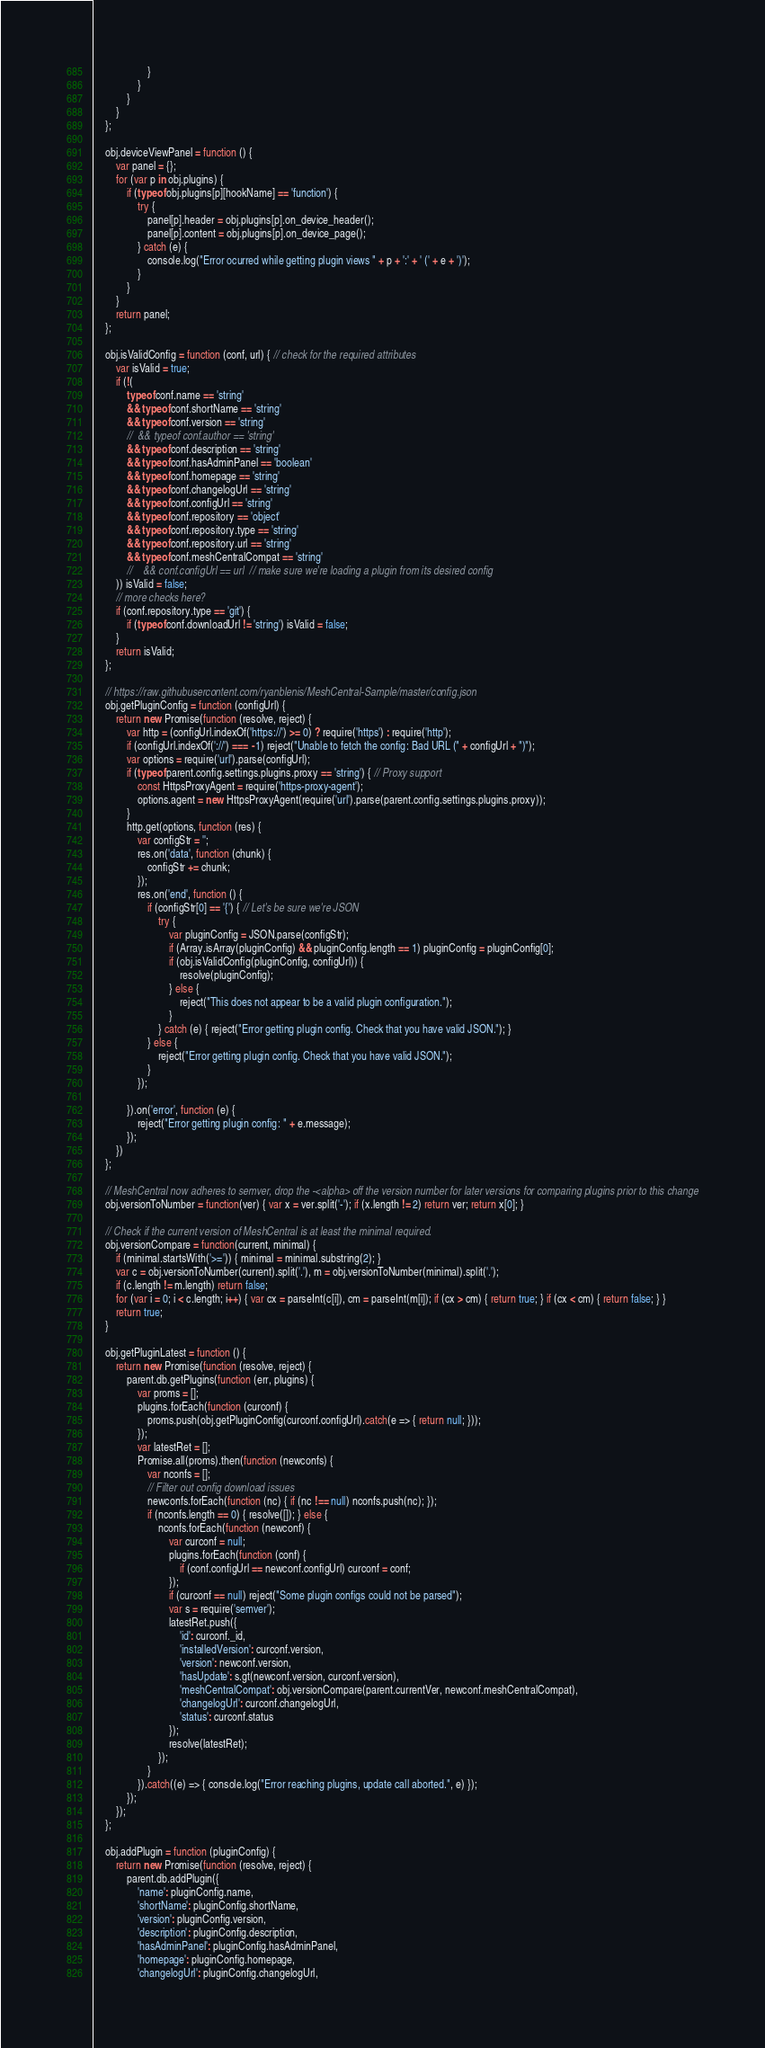<code> <loc_0><loc_0><loc_500><loc_500><_JavaScript_>                    }
                }
            }
        }
    };

    obj.deviceViewPanel = function () {
        var panel = {};
        for (var p in obj.plugins) {
            if (typeof obj.plugins[p][hookName] == 'function') {
                try {
                    panel[p].header = obj.plugins[p].on_device_header();
                    panel[p].content = obj.plugins[p].on_device_page();
                } catch (e) {
                    console.log("Error ocurred while getting plugin views " + p + ':' + ' (' + e + ')');
                }
            }
        }
        return panel;
    };

    obj.isValidConfig = function (conf, url) { // check for the required attributes
        var isValid = true;
        if (!(
            typeof conf.name == 'string'
            && typeof conf.shortName == 'string'
            && typeof conf.version == 'string'
            //  && typeof conf.author == 'string'
            && typeof conf.description == 'string'
            && typeof conf.hasAdminPanel == 'boolean'
            && typeof conf.homepage == 'string'
            && typeof conf.changelogUrl == 'string'
            && typeof conf.configUrl == 'string'
            && typeof conf.repository == 'object'
            && typeof conf.repository.type == 'string'
            && typeof conf.repository.url == 'string'
            && typeof conf.meshCentralCompat == 'string'
            //    && conf.configUrl == url  // make sure we're loading a plugin from its desired config
        )) isValid = false;
        // more checks here?
        if (conf.repository.type == 'git') {
            if (typeof conf.downloadUrl != 'string') isValid = false;
        }
        return isValid;
    };

    // https://raw.githubusercontent.com/ryanblenis/MeshCentral-Sample/master/config.json
    obj.getPluginConfig = function (configUrl) {
        return new Promise(function (resolve, reject) {
            var http = (configUrl.indexOf('https://') >= 0) ? require('https') : require('http');
            if (configUrl.indexOf('://') === -1) reject("Unable to fetch the config: Bad URL (" + configUrl + ")");
            var options = require('url').parse(configUrl);
            if (typeof parent.config.settings.plugins.proxy == 'string') { // Proxy support
                const HttpsProxyAgent = require('https-proxy-agent');
                options.agent = new HttpsProxyAgent(require('url').parse(parent.config.settings.plugins.proxy));
            }
            http.get(options, function (res) {
                var configStr = '';
                res.on('data', function (chunk) {
                    configStr += chunk;
                });
                res.on('end', function () {
                    if (configStr[0] == '{') { // Let's be sure we're JSON
                        try {
                            var pluginConfig = JSON.parse(configStr);
                            if (Array.isArray(pluginConfig) && pluginConfig.length == 1) pluginConfig = pluginConfig[0];
                            if (obj.isValidConfig(pluginConfig, configUrl)) {
                                resolve(pluginConfig);
                            } else {
                                reject("This does not appear to be a valid plugin configuration.");
                            }
                        } catch (e) { reject("Error getting plugin config. Check that you have valid JSON."); }
                    } else {
                        reject("Error getting plugin config. Check that you have valid JSON.");
                    }
                });

            }).on('error', function (e) {
                reject("Error getting plugin config: " + e.message);
            });
        })
    };

    // MeshCentral now adheres to semver, drop the -<alpha> off the version number for later versions for comparing plugins prior to this change
    obj.versionToNumber = function(ver) { var x = ver.split('-'); if (x.length != 2) return ver; return x[0]; }

    // Check if the current version of MeshCentral is at least the minimal required.
    obj.versionCompare = function(current, minimal) {
        if (minimal.startsWith('>=')) { minimal = minimal.substring(2); }
        var c = obj.versionToNumber(current).split('.'), m = obj.versionToNumber(minimal).split('.');
        if (c.length != m.length) return false;
        for (var i = 0; i < c.length; i++) { var cx = parseInt(c[i]), cm = parseInt(m[i]); if (cx > cm) { return true; } if (cx < cm) { return false; } }
        return true;
    }

    obj.getPluginLatest = function () {
        return new Promise(function (resolve, reject) {
            parent.db.getPlugins(function (err, plugins) {
                var proms = [];
                plugins.forEach(function (curconf) {
                    proms.push(obj.getPluginConfig(curconf.configUrl).catch(e => { return null; }));
                });
                var latestRet = [];
                Promise.all(proms).then(function (newconfs) {
                    var nconfs = [];
                    // Filter out config download issues
                    newconfs.forEach(function (nc) { if (nc !== null) nconfs.push(nc); });
                    if (nconfs.length == 0) { resolve([]); } else {
                        nconfs.forEach(function (newconf) {
                            var curconf = null;
                            plugins.forEach(function (conf) {
                                if (conf.configUrl == newconf.configUrl) curconf = conf;
                            });
                            if (curconf == null) reject("Some plugin configs could not be parsed");
                            var s = require('semver');
                            latestRet.push({
                                'id': curconf._id,
                                'installedVersion': curconf.version,
                                'version': newconf.version,
                                'hasUpdate': s.gt(newconf.version, curconf.version),
                                'meshCentralCompat': obj.versionCompare(parent.currentVer, newconf.meshCentralCompat),
                                'changelogUrl': curconf.changelogUrl,
                                'status': curconf.status
                            });
                            resolve(latestRet);
                        });
                    }
                }).catch((e) => { console.log("Error reaching plugins, update call aborted.", e) });
            });
        });
    };

    obj.addPlugin = function (pluginConfig) {
        return new Promise(function (resolve, reject) {
            parent.db.addPlugin({
                'name': pluginConfig.name,
                'shortName': pluginConfig.shortName,
                'version': pluginConfig.version,
                'description': pluginConfig.description,
                'hasAdminPanel': pluginConfig.hasAdminPanel,
                'homepage': pluginConfig.homepage,
                'changelogUrl': pluginConfig.changelogUrl,</code> 